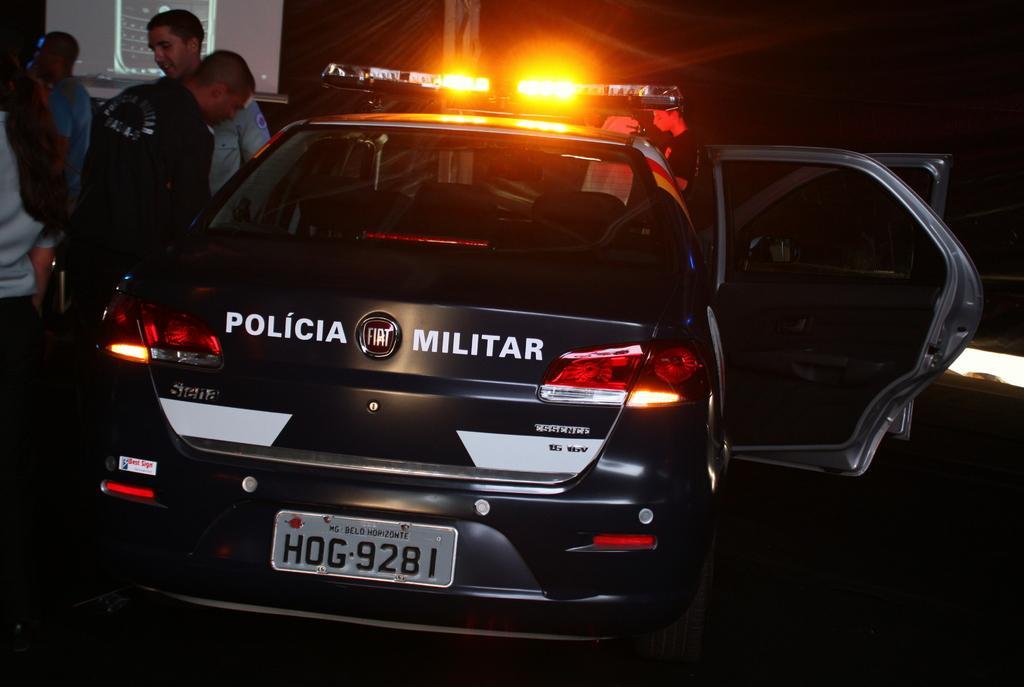Can you describe this image briefly? In this picture there are people and we can see car and screen. In the background of the image it is dark and we can see lights. 